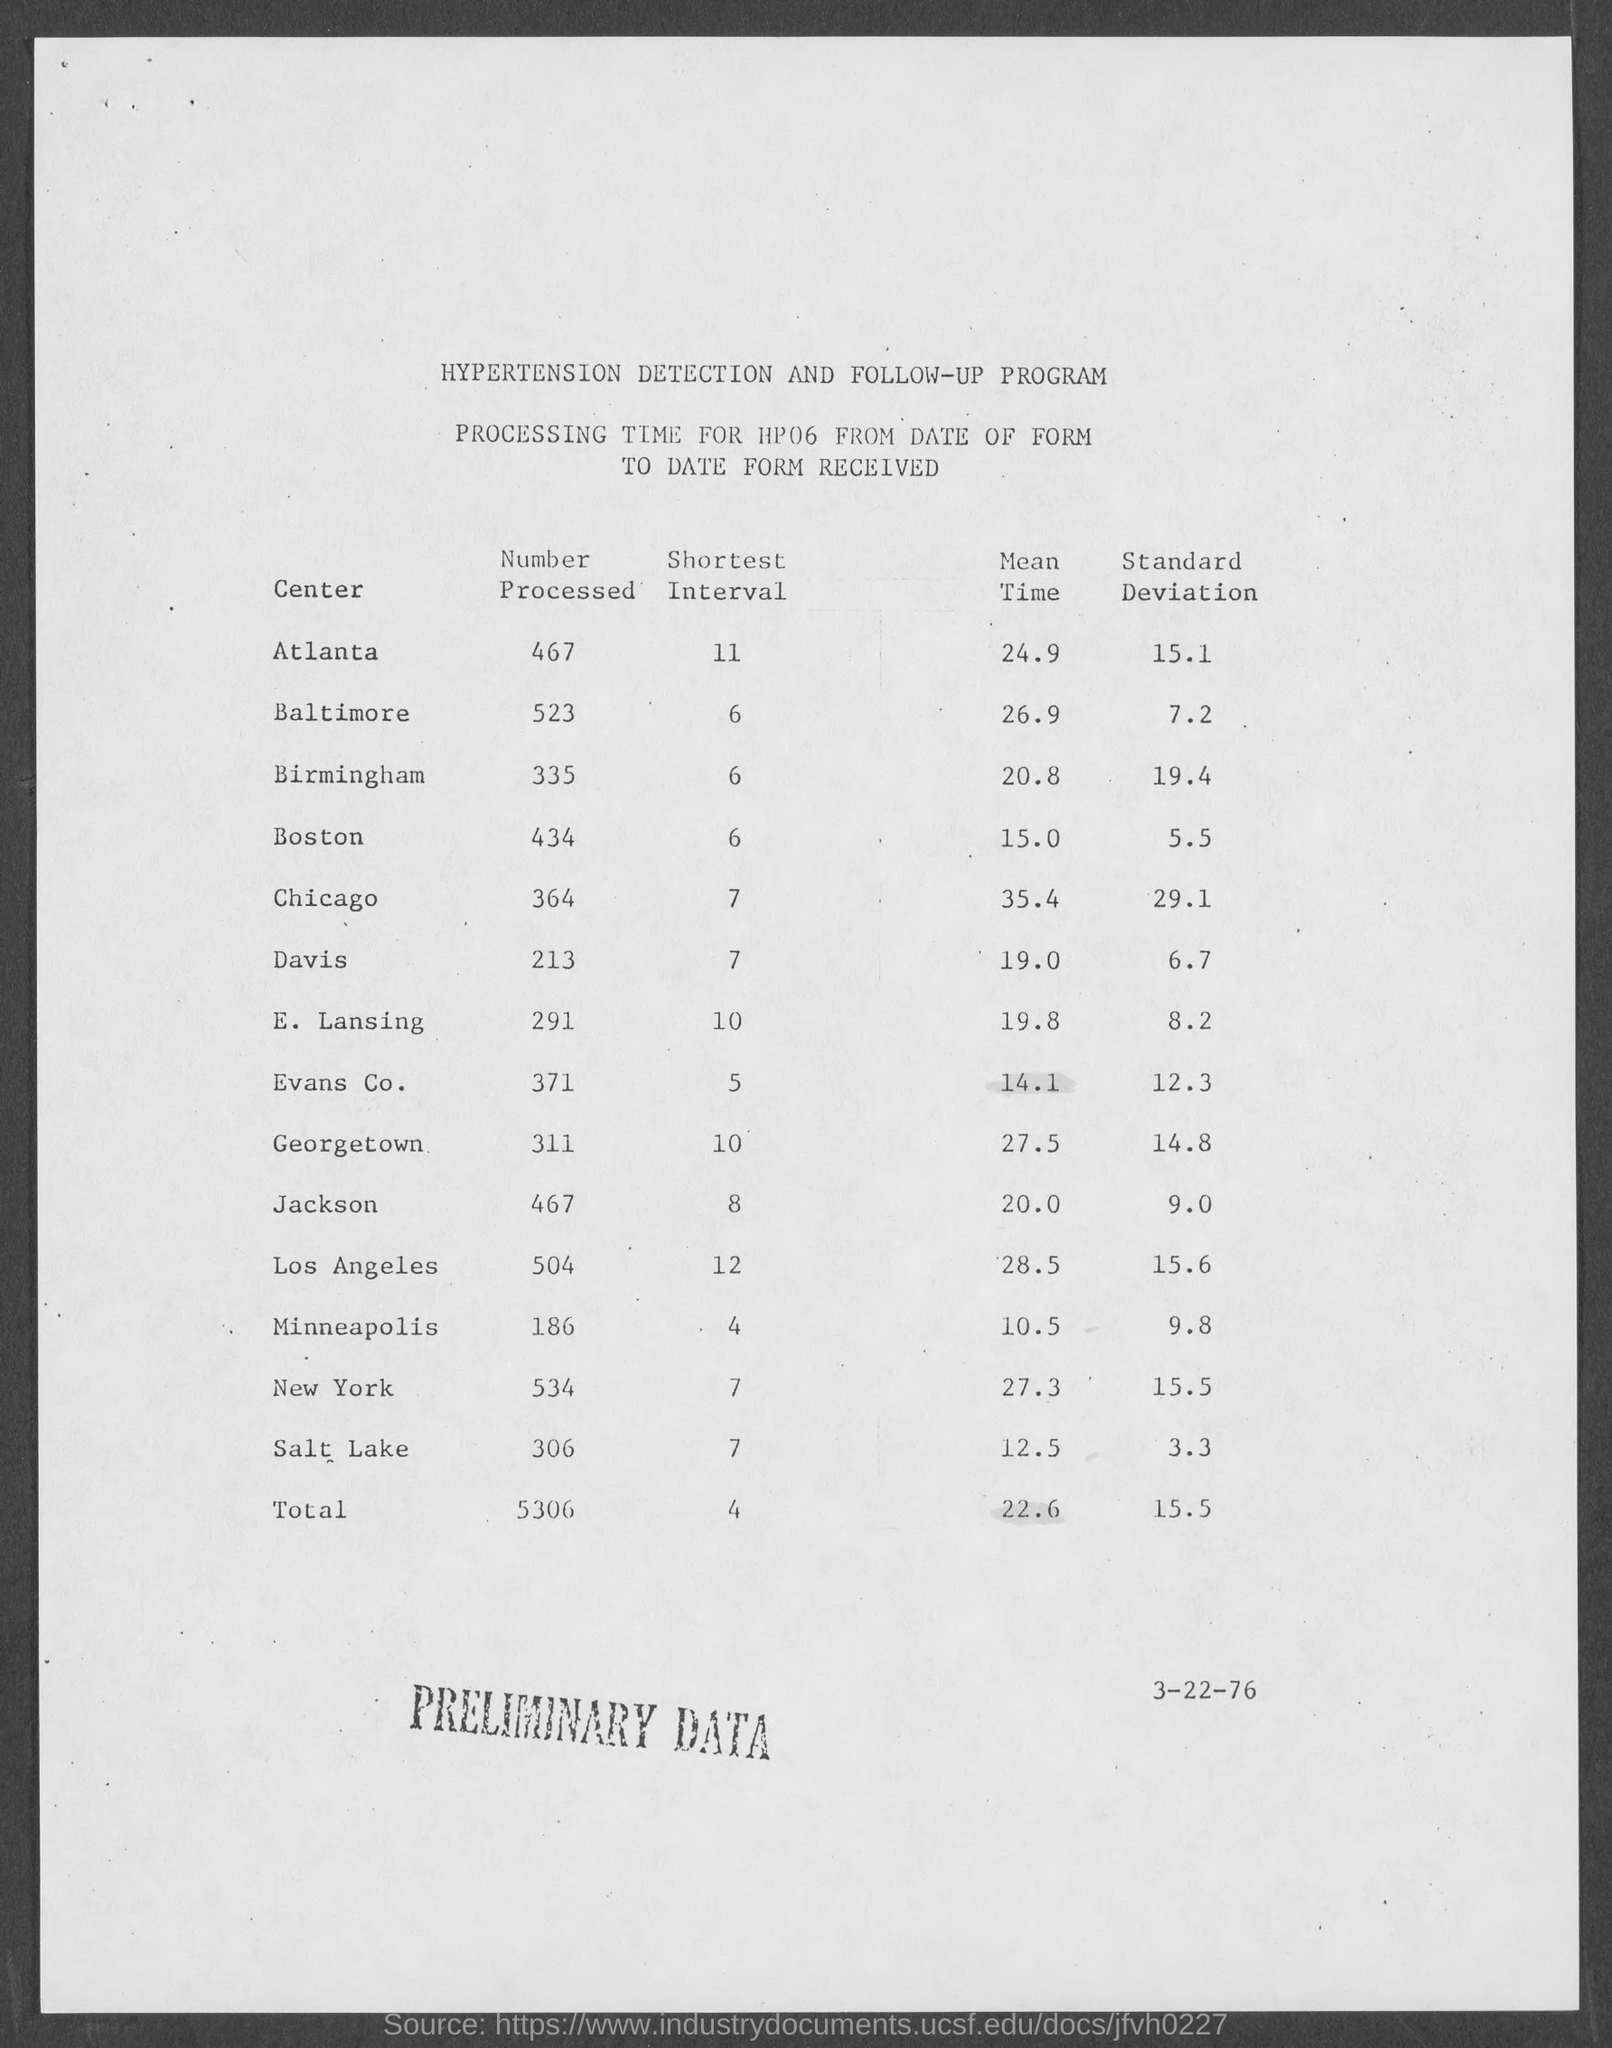What is the mean time of atlanta ?
Provide a short and direct response. 24.9. What is the total mean time ?
Ensure brevity in your answer.  22.6. What is the total standard deviation ?
Give a very brief answer. 15.5. What is the total of shortest interval ?
Provide a succinct answer. 4. What is the total of number processed ?
Provide a succinct answer. 5306. What is the mean time of davis ?
Offer a very short reply. 19.0. What is the standard deviation of  boston ?
Give a very brief answer. 5.5. What is the shortest interval of chicago
Provide a short and direct response. 7. What is the shortest interval of new york
Keep it short and to the point. 7. What is the mean time of los angeles
Ensure brevity in your answer.  28.5. 